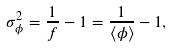Convert formula to latex. <formula><loc_0><loc_0><loc_500><loc_500>\sigma ^ { 2 } _ { \phi } = \frac { 1 } { f } - 1 = \frac { 1 } { \langle \phi \rangle } - 1 ,</formula> 